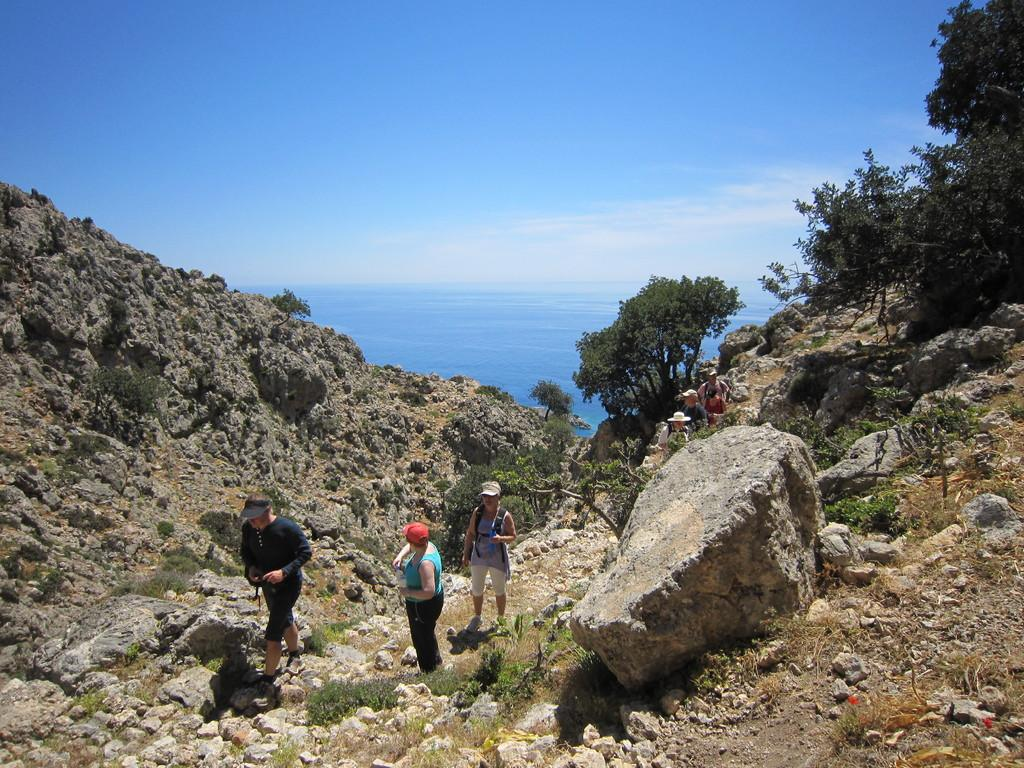What are the people in the image doing? There are persons walking in the center of the image. What type of vegetation can be seen in the image? There are trees in the image. What is on the ground in the image? There are stones on the ground. What can be seen in the background of the image? There is water visible in the background of the image. How would you describe the weather in the image? The sky is cloudy in the image. What type of cake is being attacked by the birds in the image? There is no cake or birds present in the image. Where is the church located in the image? There is no church present in the image. 